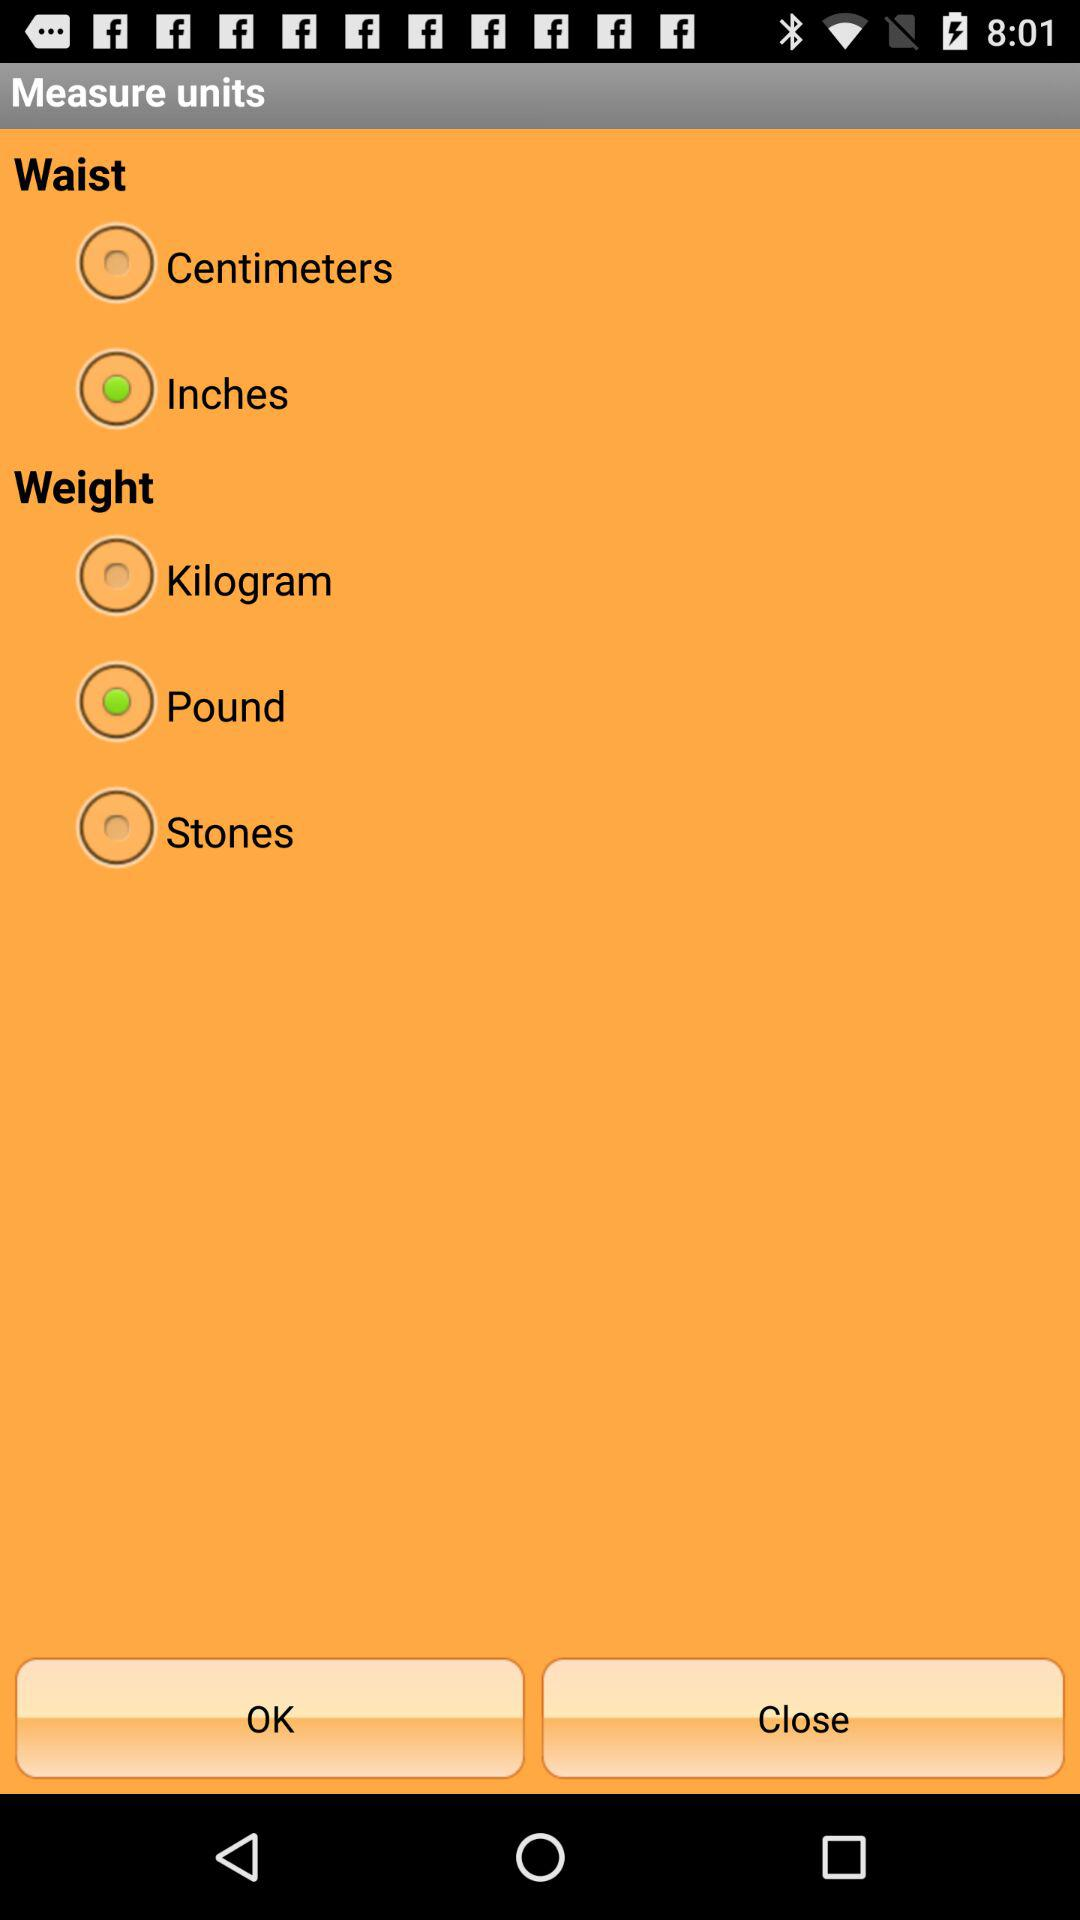Which unit is selected for measuring weight? The selected unit is pounds. 